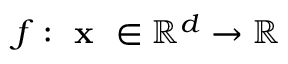Convert formula to latex. <formula><loc_0><loc_0><loc_500><loc_500>f \colon x \in \mathbb { R } ^ { d } \rightarrow \mathbb { R }</formula> 